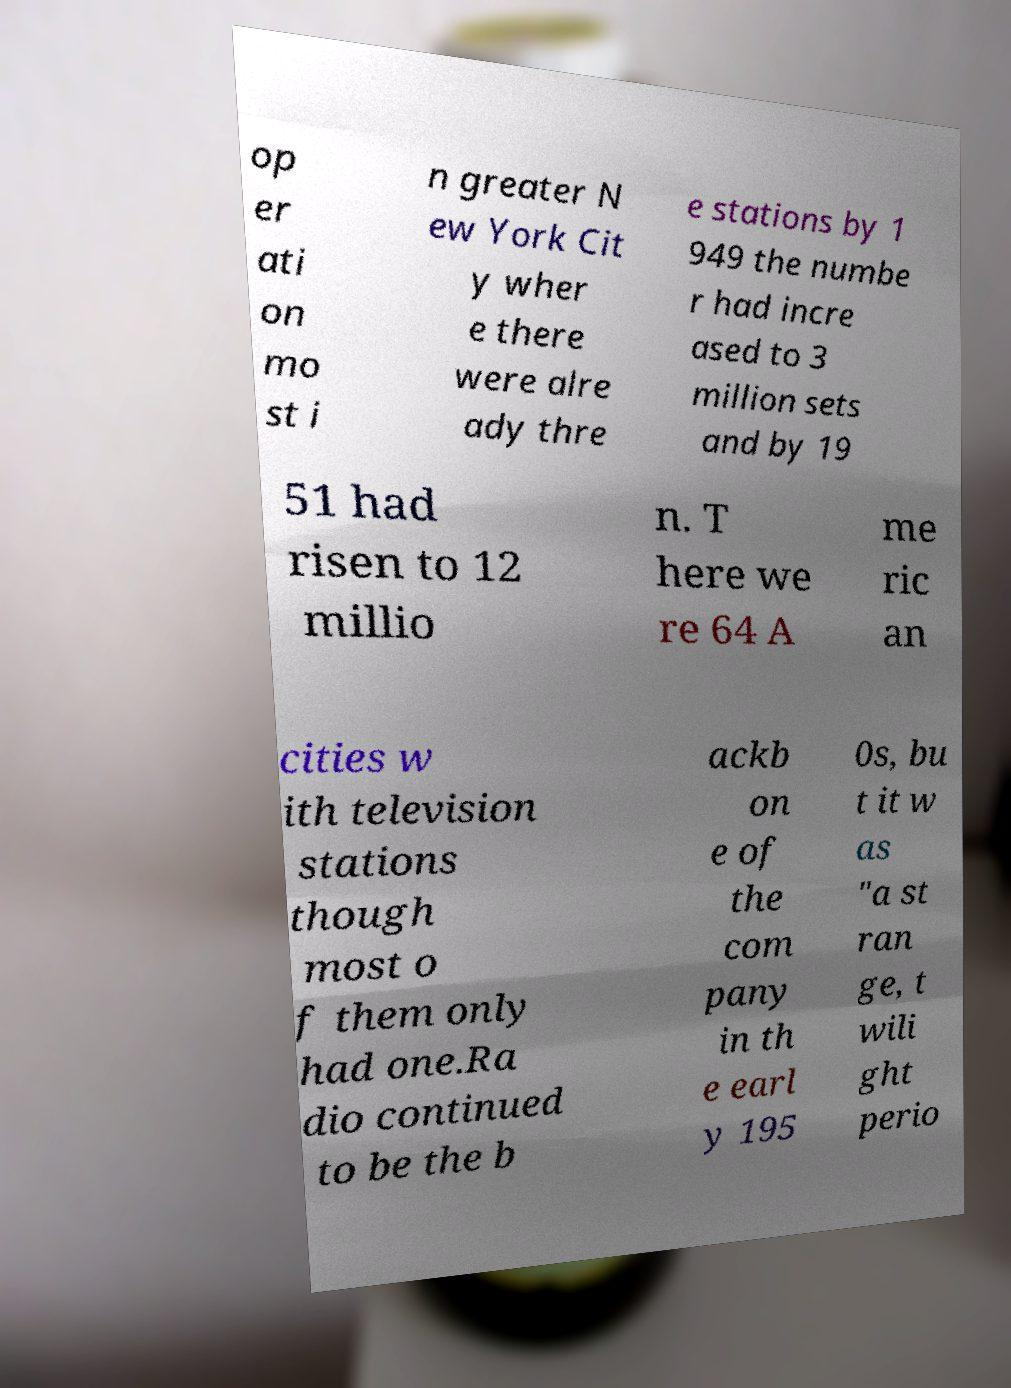What messages or text are displayed in this image? I need them in a readable, typed format. op er ati on mo st i n greater N ew York Cit y wher e there were alre ady thre e stations by 1 949 the numbe r had incre ased to 3 million sets and by 19 51 had risen to 12 millio n. T here we re 64 A me ric an cities w ith television stations though most o f them only had one.Ra dio continued to be the b ackb on e of the com pany in th e earl y 195 0s, bu t it w as "a st ran ge, t wili ght perio 